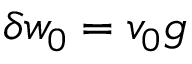<formula> <loc_0><loc_0><loc_500><loc_500>\delta w _ { 0 } = v _ { 0 } g</formula> 